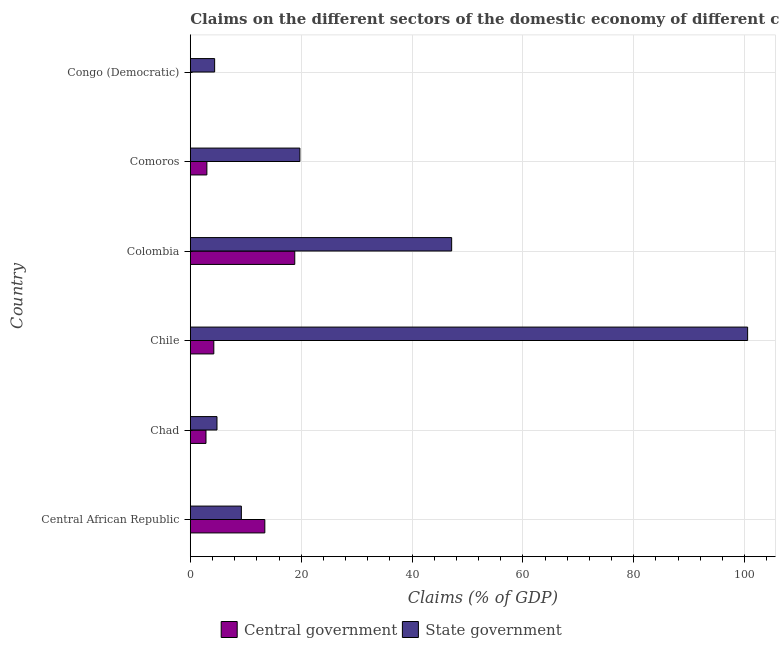Are the number of bars on each tick of the Y-axis equal?
Make the answer very short. No. How many bars are there on the 2nd tick from the top?
Make the answer very short. 2. What is the label of the 6th group of bars from the top?
Provide a succinct answer. Central African Republic. What is the claims on state government in Chile?
Your answer should be very brief. 100.53. Across all countries, what is the maximum claims on state government?
Ensure brevity in your answer.  100.53. Across all countries, what is the minimum claims on state government?
Provide a succinct answer. 4.39. What is the total claims on central government in the graph?
Keep it short and to the point. 42.36. What is the difference between the claims on state government in Chad and that in Congo (Democratic)?
Offer a very short reply. 0.42. What is the difference between the claims on state government in Colombia and the claims on central government in Congo (Democratic)?
Offer a terse response. 47.14. What is the average claims on state government per country?
Keep it short and to the point. 30.98. What is the difference between the claims on state government and claims on central government in Chad?
Give a very brief answer. 1.98. In how many countries, is the claims on state government greater than 4 %?
Your response must be concise. 6. What is the ratio of the claims on state government in Chile to that in Colombia?
Offer a terse response. 2.13. Is the claims on state government in Chile less than that in Colombia?
Provide a short and direct response. No. What is the difference between the highest and the second highest claims on central government?
Provide a short and direct response. 5.4. What is the difference between the highest and the lowest claims on central government?
Your answer should be very brief. 18.84. Is the sum of the claims on central government in Central African Republic and Colombia greater than the maximum claims on state government across all countries?
Your answer should be compact. No. What is the difference between two consecutive major ticks on the X-axis?
Your answer should be compact. 20. Does the graph contain grids?
Keep it short and to the point. Yes. Where does the legend appear in the graph?
Your answer should be compact. Bottom center. How many legend labels are there?
Make the answer very short. 2. How are the legend labels stacked?
Give a very brief answer. Horizontal. What is the title of the graph?
Provide a short and direct response. Claims on the different sectors of the domestic economy of different countries. What is the label or title of the X-axis?
Make the answer very short. Claims (% of GDP). What is the Claims (% of GDP) of Central government in Central African Republic?
Your response must be concise. 13.45. What is the Claims (% of GDP) in State government in Central African Republic?
Offer a very short reply. 9.21. What is the Claims (% of GDP) of Central government in Chad?
Keep it short and to the point. 2.83. What is the Claims (% of GDP) in State government in Chad?
Provide a succinct answer. 4.81. What is the Claims (% of GDP) of Central government in Chile?
Make the answer very short. 4.24. What is the Claims (% of GDP) of State government in Chile?
Your answer should be compact. 100.53. What is the Claims (% of GDP) of Central government in Colombia?
Keep it short and to the point. 18.84. What is the Claims (% of GDP) in State government in Colombia?
Make the answer very short. 47.14. What is the Claims (% of GDP) in Central government in Comoros?
Give a very brief answer. 2.99. What is the Claims (% of GDP) in State government in Comoros?
Give a very brief answer. 19.77. What is the Claims (% of GDP) in Central government in Congo (Democratic)?
Provide a short and direct response. 0. What is the Claims (% of GDP) in State government in Congo (Democratic)?
Keep it short and to the point. 4.39. Across all countries, what is the maximum Claims (% of GDP) in Central government?
Give a very brief answer. 18.84. Across all countries, what is the maximum Claims (% of GDP) in State government?
Your response must be concise. 100.53. Across all countries, what is the minimum Claims (% of GDP) of Central government?
Make the answer very short. 0. Across all countries, what is the minimum Claims (% of GDP) in State government?
Your answer should be compact. 4.39. What is the total Claims (% of GDP) of Central government in the graph?
Your answer should be compact. 42.36. What is the total Claims (% of GDP) of State government in the graph?
Offer a very short reply. 185.86. What is the difference between the Claims (% of GDP) of Central government in Central African Republic and that in Chad?
Keep it short and to the point. 10.61. What is the difference between the Claims (% of GDP) of State government in Central African Republic and that in Chad?
Your answer should be very brief. 4.4. What is the difference between the Claims (% of GDP) of Central government in Central African Republic and that in Chile?
Offer a terse response. 9.2. What is the difference between the Claims (% of GDP) in State government in Central African Republic and that in Chile?
Your answer should be compact. -91.32. What is the difference between the Claims (% of GDP) of Central government in Central African Republic and that in Colombia?
Give a very brief answer. -5.4. What is the difference between the Claims (% of GDP) of State government in Central African Republic and that in Colombia?
Give a very brief answer. -37.93. What is the difference between the Claims (% of GDP) of Central government in Central African Republic and that in Comoros?
Keep it short and to the point. 10.45. What is the difference between the Claims (% of GDP) in State government in Central African Republic and that in Comoros?
Provide a short and direct response. -10.56. What is the difference between the Claims (% of GDP) in State government in Central African Republic and that in Congo (Democratic)?
Your response must be concise. 4.82. What is the difference between the Claims (% of GDP) of Central government in Chad and that in Chile?
Offer a terse response. -1.41. What is the difference between the Claims (% of GDP) in State government in Chad and that in Chile?
Offer a very short reply. -95.72. What is the difference between the Claims (% of GDP) in Central government in Chad and that in Colombia?
Your answer should be very brief. -16.01. What is the difference between the Claims (% of GDP) in State government in Chad and that in Colombia?
Ensure brevity in your answer.  -42.33. What is the difference between the Claims (% of GDP) of Central government in Chad and that in Comoros?
Your answer should be compact. -0.16. What is the difference between the Claims (% of GDP) in State government in Chad and that in Comoros?
Your response must be concise. -14.95. What is the difference between the Claims (% of GDP) of State government in Chad and that in Congo (Democratic)?
Offer a terse response. 0.42. What is the difference between the Claims (% of GDP) in Central government in Chile and that in Colombia?
Your answer should be very brief. -14.6. What is the difference between the Claims (% of GDP) of State government in Chile and that in Colombia?
Ensure brevity in your answer.  53.39. What is the difference between the Claims (% of GDP) in Central government in Chile and that in Comoros?
Provide a short and direct response. 1.25. What is the difference between the Claims (% of GDP) in State government in Chile and that in Comoros?
Keep it short and to the point. 80.76. What is the difference between the Claims (% of GDP) of State government in Chile and that in Congo (Democratic)?
Your answer should be compact. 96.14. What is the difference between the Claims (% of GDP) in Central government in Colombia and that in Comoros?
Give a very brief answer. 15.85. What is the difference between the Claims (% of GDP) in State government in Colombia and that in Comoros?
Ensure brevity in your answer.  27.38. What is the difference between the Claims (% of GDP) in State government in Colombia and that in Congo (Democratic)?
Your answer should be compact. 42.75. What is the difference between the Claims (% of GDP) in State government in Comoros and that in Congo (Democratic)?
Ensure brevity in your answer.  15.38. What is the difference between the Claims (% of GDP) of Central government in Central African Republic and the Claims (% of GDP) of State government in Chad?
Make the answer very short. 8.63. What is the difference between the Claims (% of GDP) of Central government in Central African Republic and the Claims (% of GDP) of State government in Chile?
Offer a very short reply. -87.09. What is the difference between the Claims (% of GDP) in Central government in Central African Republic and the Claims (% of GDP) in State government in Colombia?
Provide a short and direct response. -33.7. What is the difference between the Claims (% of GDP) in Central government in Central African Republic and the Claims (% of GDP) in State government in Comoros?
Offer a very short reply. -6.32. What is the difference between the Claims (% of GDP) in Central government in Central African Republic and the Claims (% of GDP) in State government in Congo (Democratic)?
Offer a very short reply. 9.05. What is the difference between the Claims (% of GDP) in Central government in Chad and the Claims (% of GDP) in State government in Chile?
Your answer should be very brief. -97.7. What is the difference between the Claims (% of GDP) in Central government in Chad and the Claims (% of GDP) in State government in Colombia?
Offer a terse response. -44.31. What is the difference between the Claims (% of GDP) of Central government in Chad and the Claims (% of GDP) of State government in Comoros?
Make the answer very short. -16.94. What is the difference between the Claims (% of GDP) of Central government in Chad and the Claims (% of GDP) of State government in Congo (Democratic)?
Give a very brief answer. -1.56. What is the difference between the Claims (% of GDP) of Central government in Chile and the Claims (% of GDP) of State government in Colombia?
Provide a short and direct response. -42.9. What is the difference between the Claims (% of GDP) in Central government in Chile and the Claims (% of GDP) in State government in Comoros?
Give a very brief answer. -15.52. What is the difference between the Claims (% of GDP) in Central government in Chile and the Claims (% of GDP) in State government in Congo (Democratic)?
Provide a succinct answer. -0.15. What is the difference between the Claims (% of GDP) of Central government in Colombia and the Claims (% of GDP) of State government in Comoros?
Make the answer very short. -0.92. What is the difference between the Claims (% of GDP) in Central government in Colombia and the Claims (% of GDP) in State government in Congo (Democratic)?
Offer a terse response. 14.45. What is the difference between the Claims (% of GDP) of Central government in Comoros and the Claims (% of GDP) of State government in Congo (Democratic)?
Make the answer very short. -1.4. What is the average Claims (% of GDP) in Central government per country?
Keep it short and to the point. 7.06. What is the average Claims (% of GDP) in State government per country?
Ensure brevity in your answer.  30.98. What is the difference between the Claims (% of GDP) in Central government and Claims (% of GDP) in State government in Central African Republic?
Your answer should be very brief. 4.23. What is the difference between the Claims (% of GDP) in Central government and Claims (% of GDP) in State government in Chad?
Provide a short and direct response. -1.98. What is the difference between the Claims (% of GDP) of Central government and Claims (% of GDP) of State government in Chile?
Your answer should be very brief. -96.29. What is the difference between the Claims (% of GDP) of Central government and Claims (% of GDP) of State government in Colombia?
Give a very brief answer. -28.3. What is the difference between the Claims (% of GDP) in Central government and Claims (% of GDP) in State government in Comoros?
Offer a terse response. -16.78. What is the ratio of the Claims (% of GDP) of Central government in Central African Republic to that in Chad?
Give a very brief answer. 4.75. What is the ratio of the Claims (% of GDP) of State government in Central African Republic to that in Chad?
Provide a succinct answer. 1.91. What is the ratio of the Claims (% of GDP) of Central government in Central African Republic to that in Chile?
Give a very brief answer. 3.17. What is the ratio of the Claims (% of GDP) in State government in Central African Republic to that in Chile?
Ensure brevity in your answer.  0.09. What is the ratio of the Claims (% of GDP) in Central government in Central African Republic to that in Colombia?
Your answer should be compact. 0.71. What is the ratio of the Claims (% of GDP) of State government in Central African Republic to that in Colombia?
Offer a terse response. 0.2. What is the ratio of the Claims (% of GDP) of Central government in Central African Republic to that in Comoros?
Your response must be concise. 4.5. What is the ratio of the Claims (% of GDP) of State government in Central African Republic to that in Comoros?
Your answer should be very brief. 0.47. What is the ratio of the Claims (% of GDP) in State government in Central African Republic to that in Congo (Democratic)?
Make the answer very short. 2.1. What is the ratio of the Claims (% of GDP) of Central government in Chad to that in Chile?
Offer a terse response. 0.67. What is the ratio of the Claims (% of GDP) in State government in Chad to that in Chile?
Provide a succinct answer. 0.05. What is the ratio of the Claims (% of GDP) in Central government in Chad to that in Colombia?
Ensure brevity in your answer.  0.15. What is the ratio of the Claims (% of GDP) of State government in Chad to that in Colombia?
Ensure brevity in your answer.  0.1. What is the ratio of the Claims (% of GDP) of Central government in Chad to that in Comoros?
Your response must be concise. 0.95. What is the ratio of the Claims (% of GDP) of State government in Chad to that in Comoros?
Your response must be concise. 0.24. What is the ratio of the Claims (% of GDP) in State government in Chad to that in Congo (Democratic)?
Provide a short and direct response. 1.1. What is the ratio of the Claims (% of GDP) of Central government in Chile to that in Colombia?
Your answer should be very brief. 0.23. What is the ratio of the Claims (% of GDP) in State government in Chile to that in Colombia?
Offer a terse response. 2.13. What is the ratio of the Claims (% of GDP) of Central government in Chile to that in Comoros?
Make the answer very short. 1.42. What is the ratio of the Claims (% of GDP) in State government in Chile to that in Comoros?
Offer a terse response. 5.09. What is the ratio of the Claims (% of GDP) in State government in Chile to that in Congo (Democratic)?
Offer a very short reply. 22.9. What is the ratio of the Claims (% of GDP) of Central government in Colombia to that in Comoros?
Offer a very short reply. 6.3. What is the ratio of the Claims (% of GDP) of State government in Colombia to that in Comoros?
Offer a terse response. 2.38. What is the ratio of the Claims (% of GDP) of State government in Colombia to that in Congo (Democratic)?
Your answer should be very brief. 10.74. What is the ratio of the Claims (% of GDP) in State government in Comoros to that in Congo (Democratic)?
Offer a very short reply. 4.5. What is the difference between the highest and the second highest Claims (% of GDP) of Central government?
Ensure brevity in your answer.  5.4. What is the difference between the highest and the second highest Claims (% of GDP) in State government?
Your response must be concise. 53.39. What is the difference between the highest and the lowest Claims (% of GDP) of Central government?
Offer a very short reply. 18.84. What is the difference between the highest and the lowest Claims (% of GDP) in State government?
Provide a succinct answer. 96.14. 